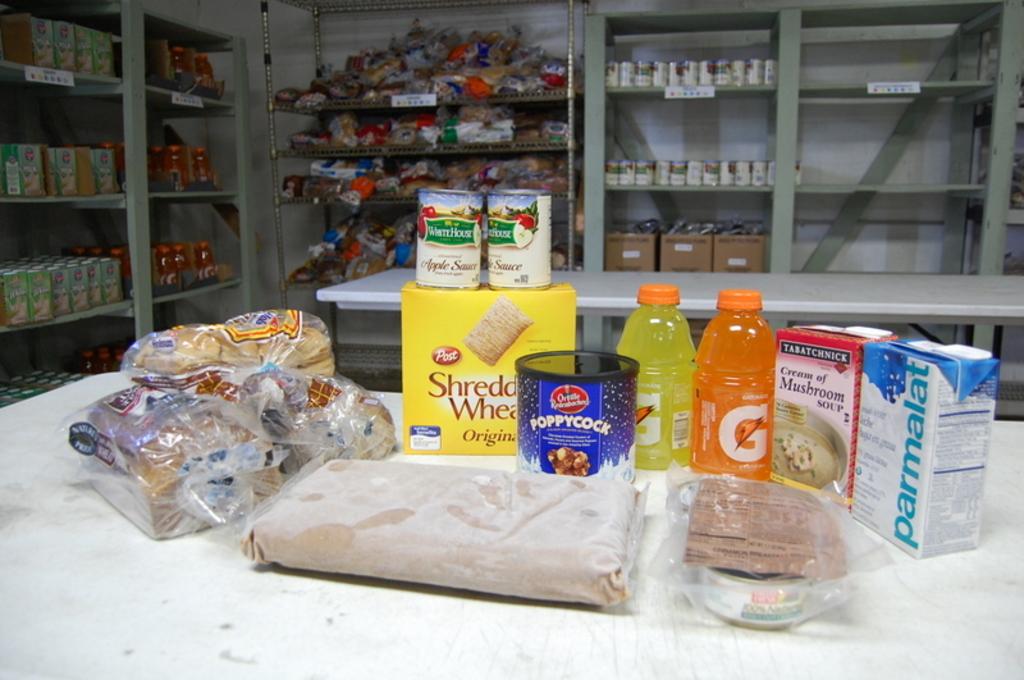What brand is the cereal?
Your answer should be very brief. Post. 